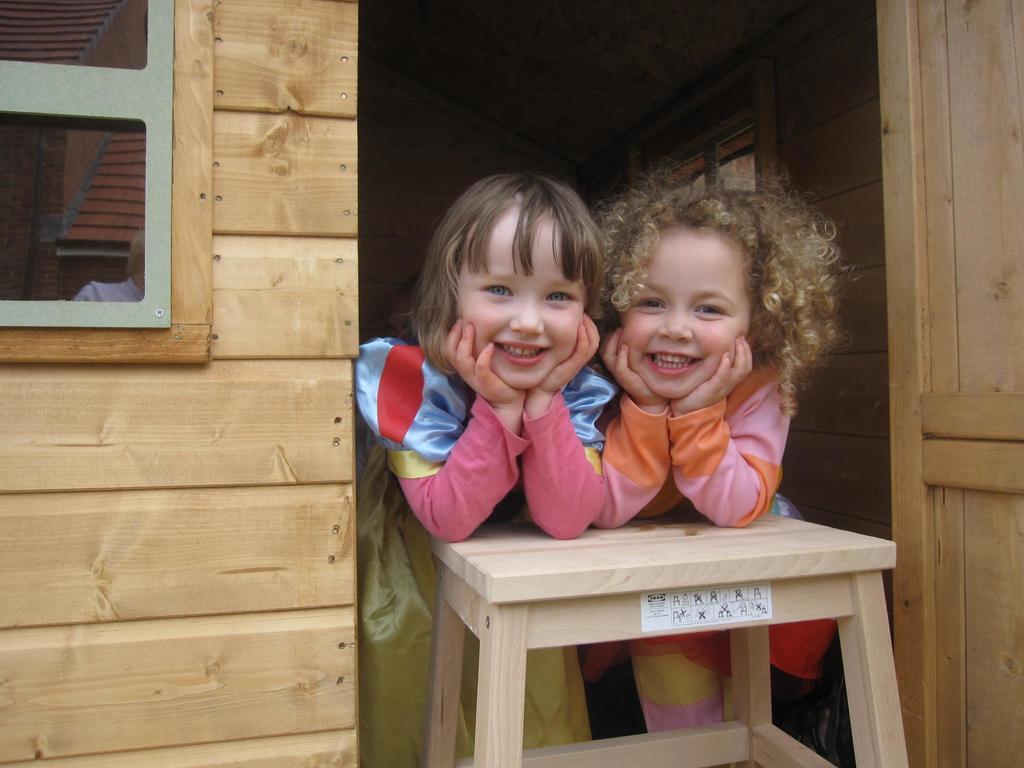In one or two sentences, can you explain what this image depicts? Here there are 2 girls smiling,they placed their hands on a stool. Behind them there is a wall. 